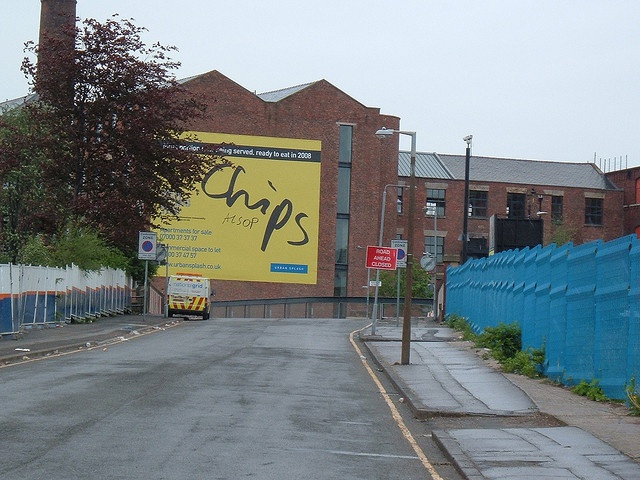Describe the objects in this image and their specific colors. I can see a truck in lightgray, darkgray, black, tan, and gray tones in this image. 